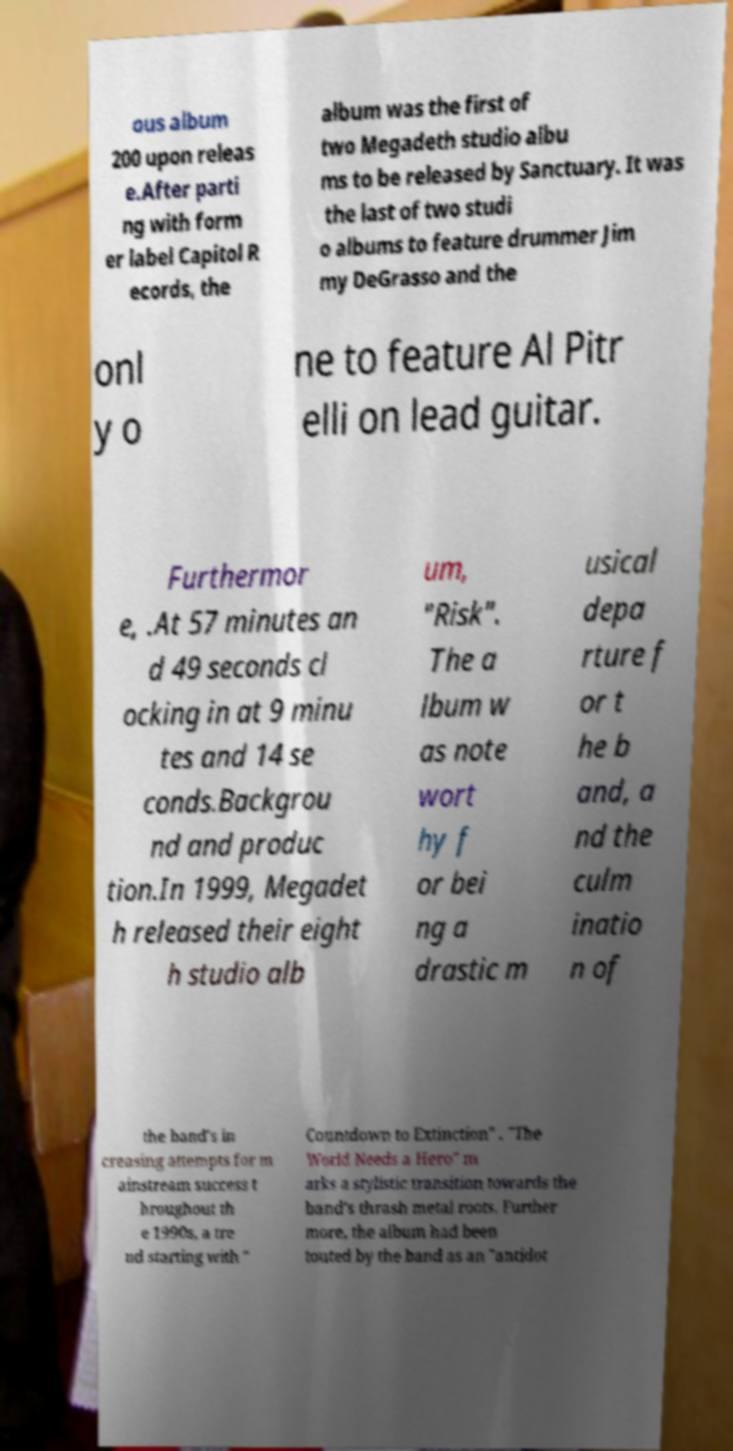Can you read and provide the text displayed in the image?This photo seems to have some interesting text. Can you extract and type it out for me? ous album 200 upon releas e.After parti ng with form er label Capitol R ecords, the album was the first of two Megadeth studio albu ms to be released by Sanctuary. It was the last of two studi o albums to feature drummer Jim my DeGrasso and the onl y o ne to feature Al Pitr elli on lead guitar. Furthermor e, .At 57 minutes an d 49 seconds cl ocking in at 9 minu tes and 14 se conds.Backgrou nd and produc tion.In 1999, Megadet h released their eight h studio alb um, "Risk". The a lbum w as note wort hy f or bei ng a drastic m usical depa rture f or t he b and, a nd the culm inatio n of the band's in creasing attempts for m ainstream success t hroughout th e 1990s, a tre nd starting with " Countdown to Extinction" . "The World Needs a Hero" m arks a stylistic transition towards the band's thrash metal roots. Further more, the album had been touted by the band as an "antidot 